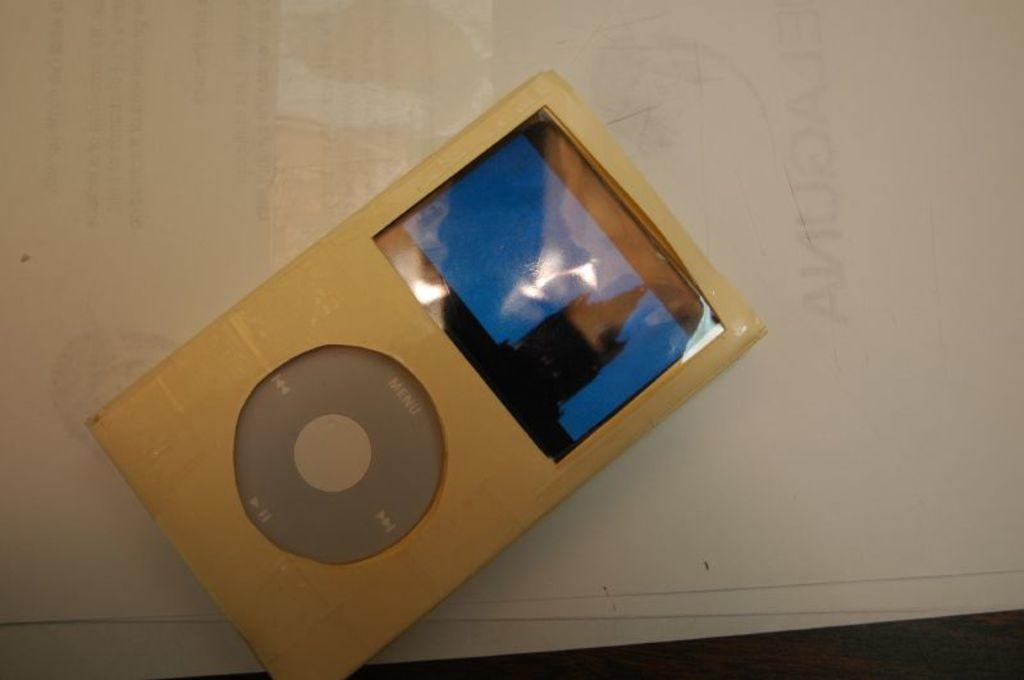What object in the image resembles a remote control? There is an object that looks like a remote in the image. What is the color of the surface on which the object is placed? The object is on a white surface. How many planes can be seen flying in the image? There are no planes visible in the image. Is there a tiger present in the image? No, there is no tiger in the image. 